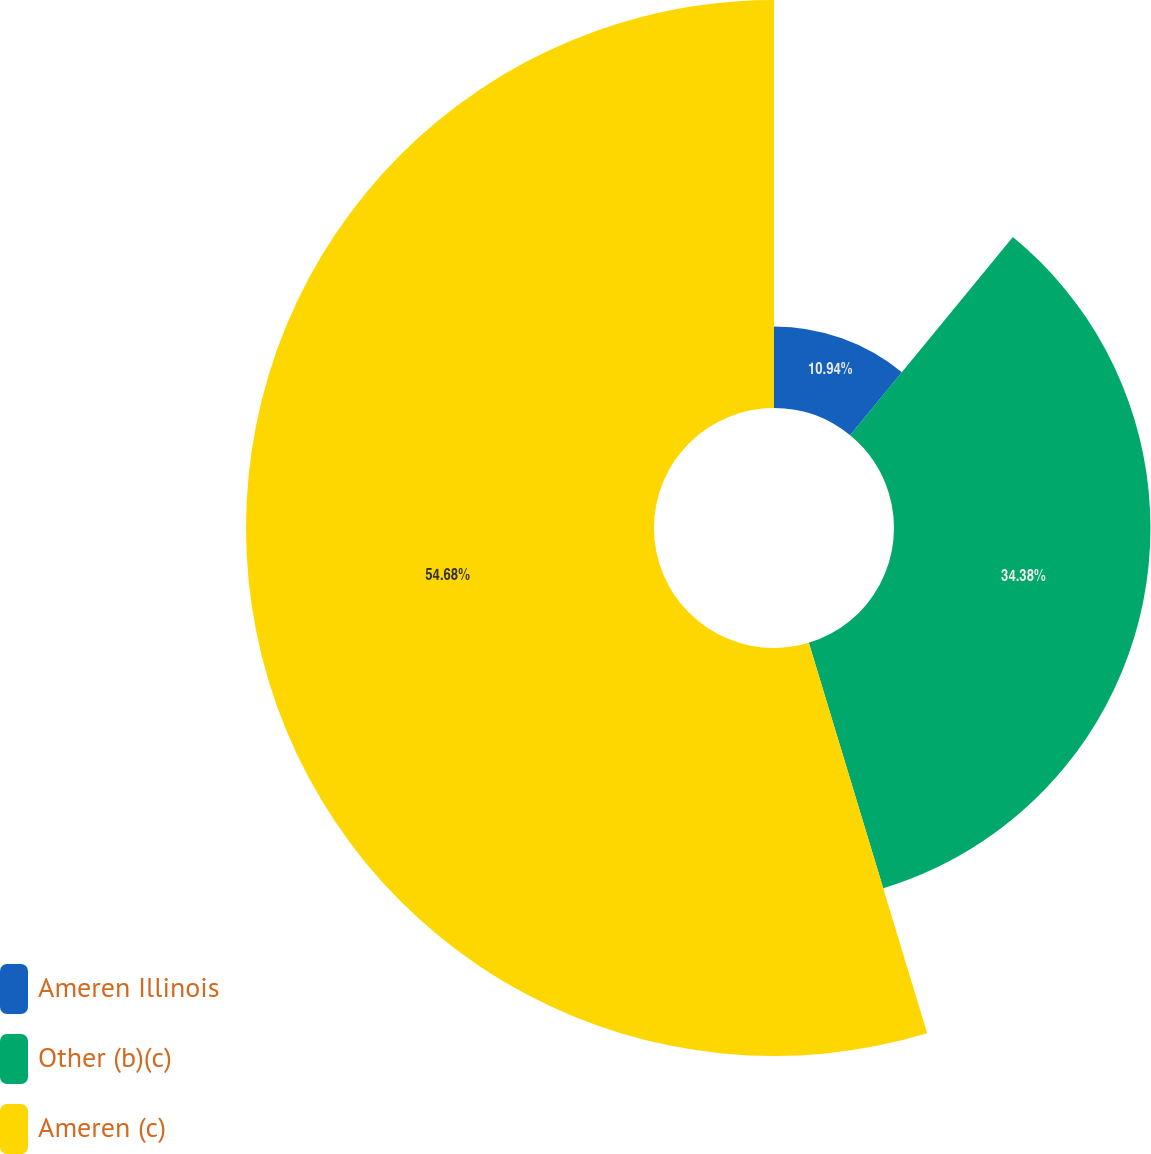Convert chart. <chart><loc_0><loc_0><loc_500><loc_500><pie_chart><fcel>Ameren Illinois<fcel>Other (b)(c)<fcel>Ameren (c)<nl><fcel>10.94%<fcel>34.38%<fcel>54.69%<nl></chart> 